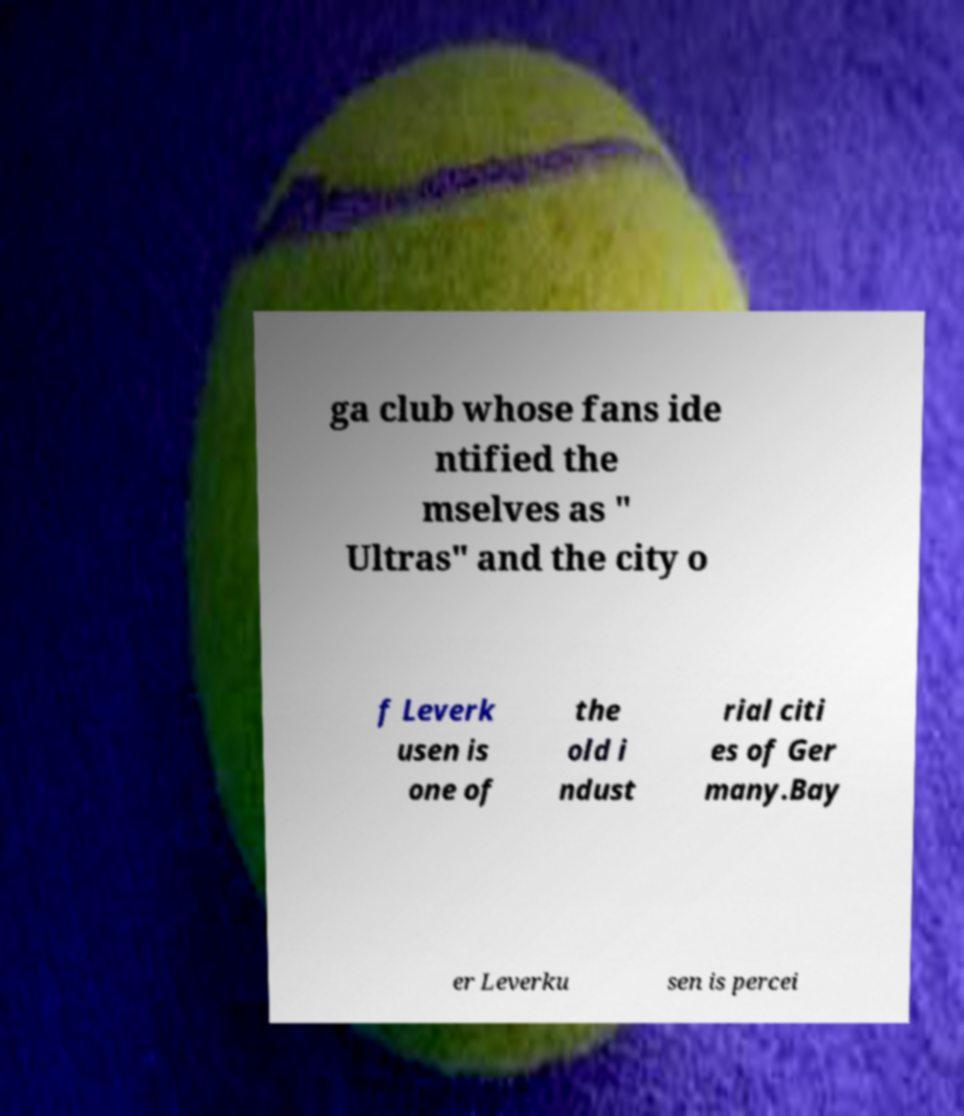Could you assist in decoding the text presented in this image and type it out clearly? ga club whose fans ide ntified the mselves as " Ultras" and the city o f Leverk usen is one of the old i ndust rial citi es of Ger many.Bay er Leverku sen is percei 